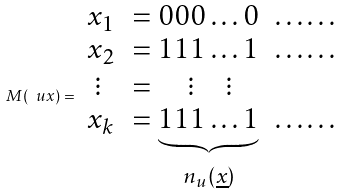<formula> <loc_0><loc_0><loc_500><loc_500>M ( \ u x ) = \begin{array} { l l l } x _ { 1 } & = 0 0 0 \dots 0 & \dots \dots \\ x _ { 2 } & = 1 1 1 \dots 1 & \dots \dots \\ \ \vdots & = \quad \vdots \quad \vdots & \\ x _ { k } & = \underbrace { 1 1 1 \dots 1 } _ { n _ { u } ( \underline { x } ) } & \dots \dots \end{array}</formula> 